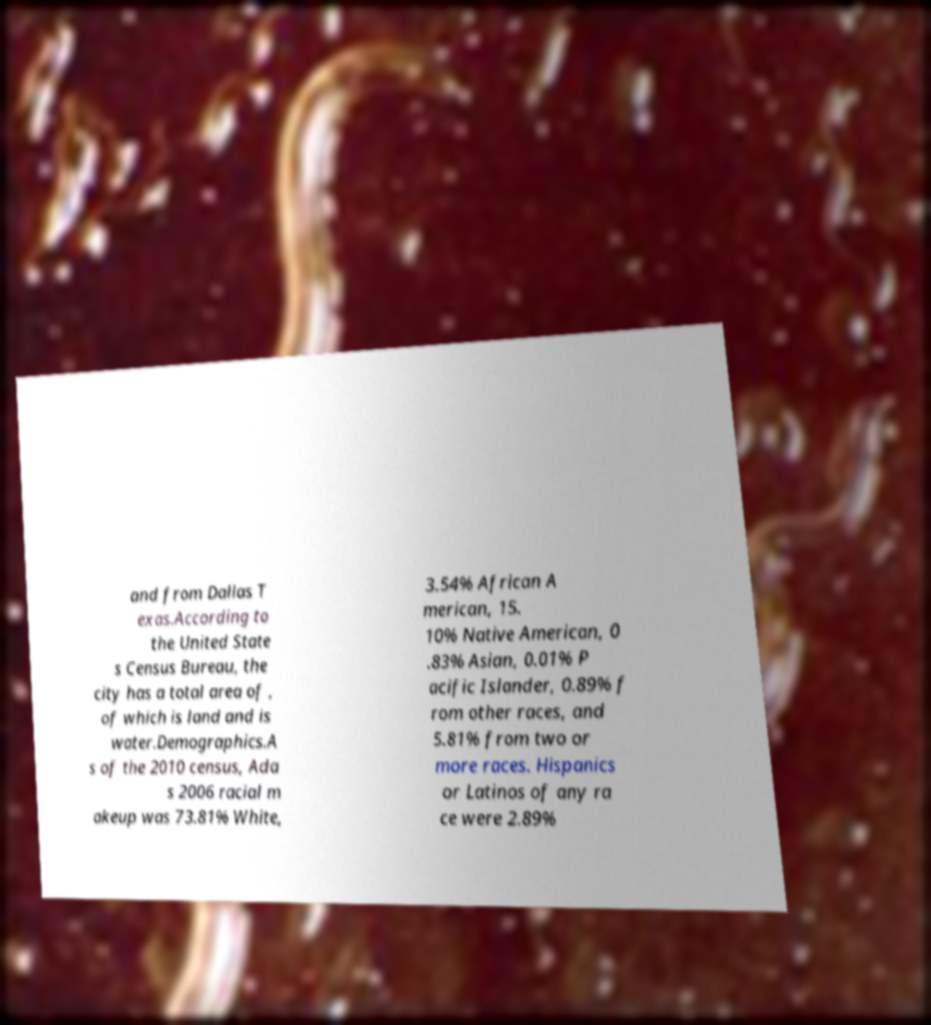There's text embedded in this image that I need extracted. Can you transcribe it verbatim? and from Dallas T exas.According to the United State s Census Bureau, the city has a total area of , of which is land and is water.Demographics.A s of the 2010 census, Ada s 2006 racial m akeup was 73.81% White, 3.54% African A merican, 15. 10% Native American, 0 .83% Asian, 0.01% P acific Islander, 0.89% f rom other races, and 5.81% from two or more races. Hispanics or Latinos of any ra ce were 2.89% 